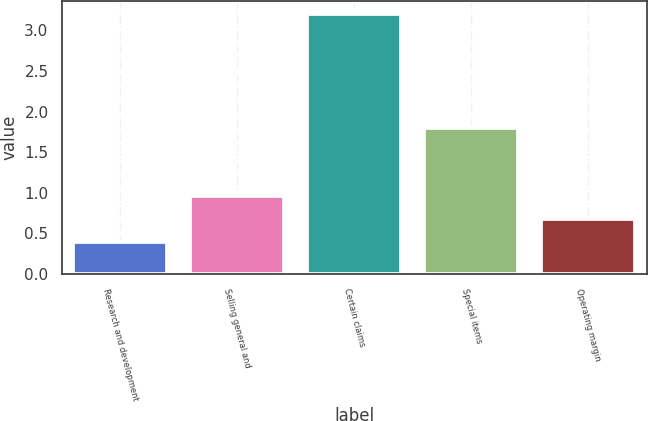Convert chart to OTSL. <chart><loc_0><loc_0><loc_500><loc_500><bar_chart><fcel>Research and development<fcel>Selling general and<fcel>Certain claims<fcel>Special items<fcel>Operating margin<nl><fcel>0.4<fcel>0.96<fcel>3.2<fcel>1.8<fcel>0.68<nl></chart> 